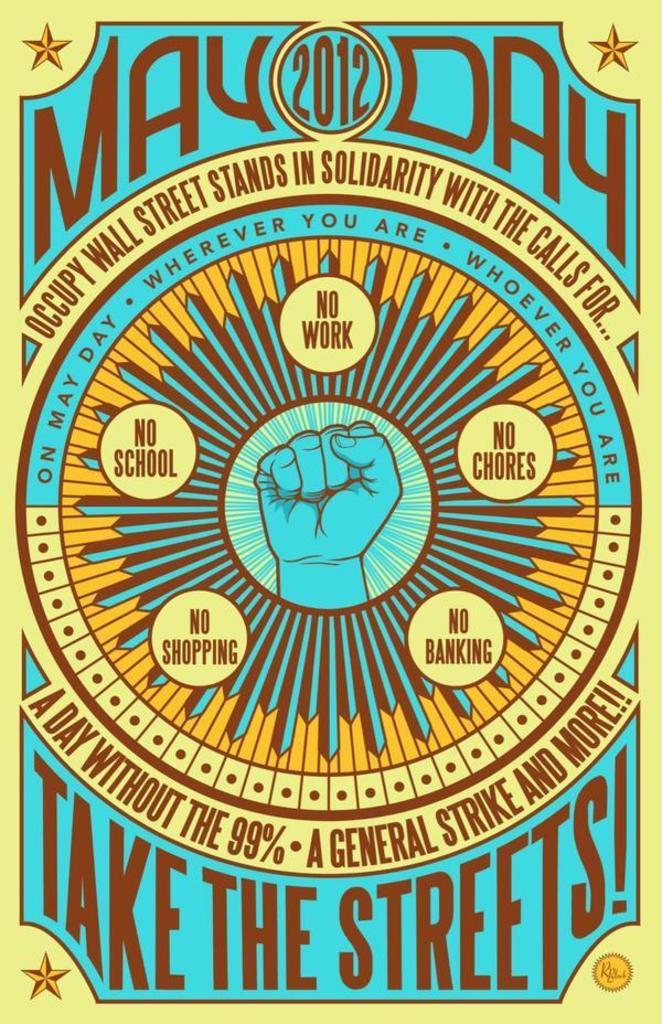<image>
Describe the image concisely. A poster fo occupy wall street with the text may day take the streets on the top and bottom. 